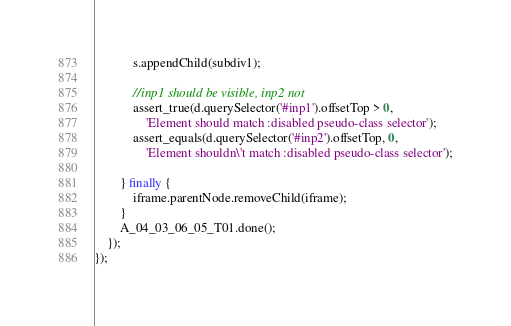Convert code to text. <code><loc_0><loc_0><loc_500><loc_500><_JavaScript_>            s.appendChild(subdiv1);

            //inp1 should be visible, inp2 not
            assert_true(d.querySelector('#inp1').offsetTop > 0,
                'Element should match :disabled pseudo-class selector');
            assert_equals(d.querySelector('#inp2').offsetTop, 0,
                'Element shouldn\'t match :disabled pseudo-class selector');

        } finally {
            iframe.parentNode.removeChild(iframe);
        }
        A_04_03_06_05_T01.done();
    });
});
</code> 